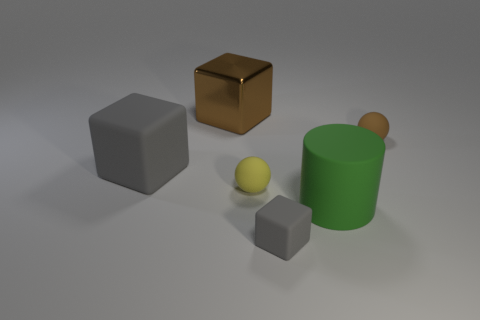Add 4 small green rubber objects. How many objects exist? 10 Subtract all cylinders. How many objects are left? 5 Subtract all small gray blocks. Subtract all brown metal balls. How many objects are left? 5 Add 4 brown shiny things. How many brown shiny things are left? 5 Add 3 small red cylinders. How many small red cylinders exist? 3 Subtract 1 brown spheres. How many objects are left? 5 